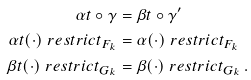Convert formula to latex. <formula><loc_0><loc_0><loc_500><loc_500>\alpha t \circ \gamma & = \beta t \circ \gamma ^ { \prime } \\ \alpha t ( \cdot ) \ r e s t r i c t _ { F _ { k } } & = \alpha ( \cdot ) \ r e s t r i c t _ { F _ { k } } \\ \beta t ( \cdot ) \ r e s t r i c t _ { G _ { k } } & = \beta ( \cdot ) \ r e s t r i c t _ { G _ { k } } \, .</formula> 